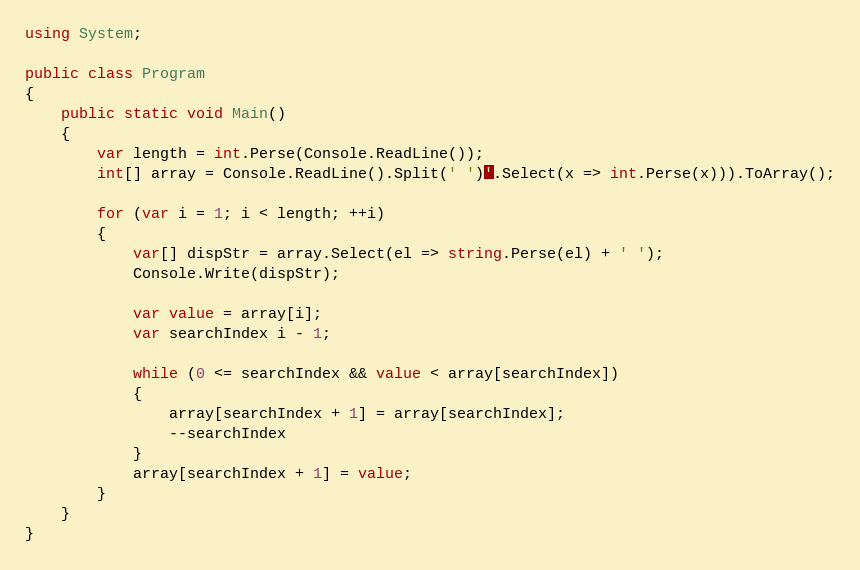Convert code to text. <code><loc_0><loc_0><loc_500><loc_500><_C#_>using System;

public class Program
{
    public static void Main()
    {
        var length = int.Perse(Console.ReadLine());
        int[] array = Console.ReadLine().Split(' ')'.Select(x => int.Perse(x))).ToArray();
        
        for (var i = 1; i < length; ++i)
        {
            var[] dispStr = array.Select(el => string.Perse(el) + ' ');
            Console.Write(dispStr);
            
            var value = array[i];
            var searchIndex i - 1;
            
            while (0 <= searchIndex && value < array[searchIndex])
            {
                array[searchIndex + 1] = array[searchIndex];
                --searchIndex
            }
            array[searchIndex + 1] = value;
        }
    }
}
</code> 